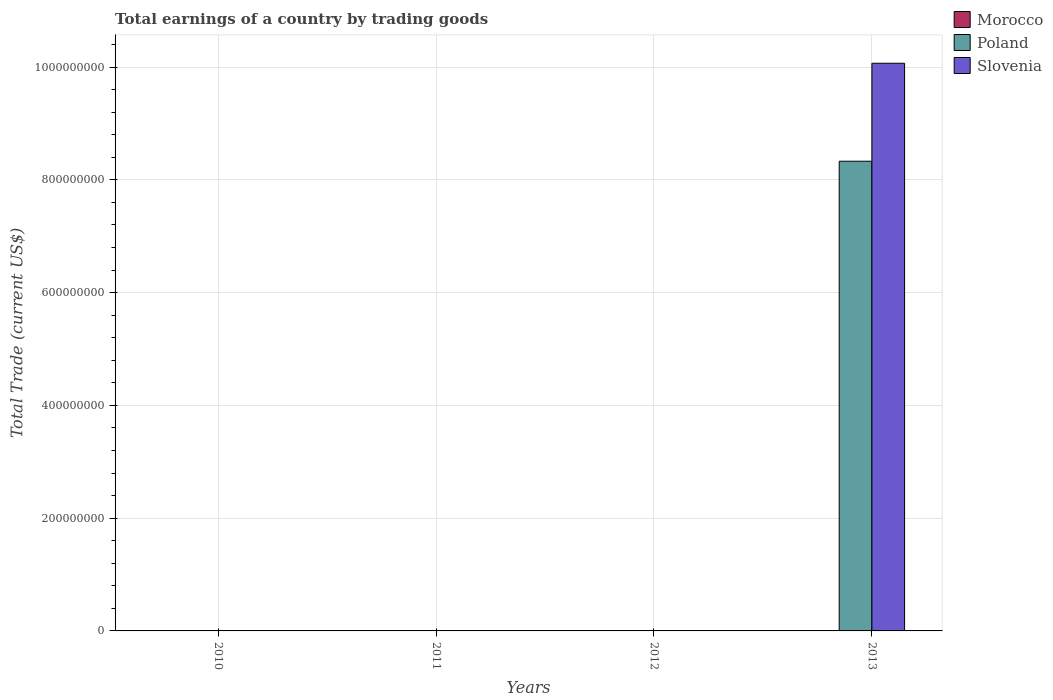How many different coloured bars are there?
Your response must be concise. 2. Are the number of bars on each tick of the X-axis equal?
Your answer should be compact. No. How many bars are there on the 1st tick from the right?
Your answer should be compact. 2. In how many cases, is the number of bars for a given year not equal to the number of legend labels?
Your answer should be compact. 4. What is the total earnings in Poland in 2012?
Provide a succinct answer. 0. Across all years, what is the maximum total earnings in Poland?
Offer a terse response. 8.33e+08. Across all years, what is the minimum total earnings in Slovenia?
Offer a very short reply. 0. What is the total total earnings in Poland in the graph?
Provide a succinct answer. 8.33e+08. What is the difference between the total earnings in Slovenia in 2010 and the total earnings in Poland in 2013?
Make the answer very short. -8.33e+08. What is the average total earnings in Poland per year?
Give a very brief answer. 2.08e+08. What is the difference between the highest and the lowest total earnings in Poland?
Provide a short and direct response. 8.33e+08. In how many years, is the total earnings in Slovenia greater than the average total earnings in Slovenia taken over all years?
Give a very brief answer. 1. How many years are there in the graph?
Ensure brevity in your answer.  4. Are the values on the major ticks of Y-axis written in scientific E-notation?
Your response must be concise. No. Does the graph contain any zero values?
Provide a short and direct response. Yes. Does the graph contain grids?
Make the answer very short. Yes. How many legend labels are there?
Your answer should be compact. 3. How are the legend labels stacked?
Your answer should be very brief. Vertical. What is the title of the graph?
Keep it short and to the point. Total earnings of a country by trading goods. Does "Tunisia" appear as one of the legend labels in the graph?
Provide a succinct answer. No. What is the label or title of the Y-axis?
Your response must be concise. Total Trade (current US$). What is the Total Trade (current US$) of Morocco in 2010?
Your response must be concise. 0. What is the Total Trade (current US$) in Poland in 2010?
Your answer should be very brief. 0. What is the Total Trade (current US$) of Poland in 2012?
Offer a terse response. 0. What is the Total Trade (current US$) of Morocco in 2013?
Provide a short and direct response. 0. What is the Total Trade (current US$) of Poland in 2013?
Keep it short and to the point. 8.33e+08. What is the Total Trade (current US$) in Slovenia in 2013?
Make the answer very short. 1.01e+09. Across all years, what is the maximum Total Trade (current US$) of Poland?
Give a very brief answer. 8.33e+08. Across all years, what is the maximum Total Trade (current US$) of Slovenia?
Ensure brevity in your answer.  1.01e+09. Across all years, what is the minimum Total Trade (current US$) in Poland?
Provide a short and direct response. 0. Across all years, what is the minimum Total Trade (current US$) in Slovenia?
Provide a short and direct response. 0. What is the total Total Trade (current US$) in Morocco in the graph?
Offer a terse response. 0. What is the total Total Trade (current US$) in Poland in the graph?
Keep it short and to the point. 8.33e+08. What is the total Total Trade (current US$) in Slovenia in the graph?
Make the answer very short. 1.01e+09. What is the average Total Trade (current US$) of Poland per year?
Provide a short and direct response. 2.08e+08. What is the average Total Trade (current US$) of Slovenia per year?
Give a very brief answer. 2.52e+08. In the year 2013, what is the difference between the Total Trade (current US$) of Poland and Total Trade (current US$) of Slovenia?
Offer a terse response. -1.74e+08. What is the difference between the highest and the lowest Total Trade (current US$) of Poland?
Make the answer very short. 8.33e+08. What is the difference between the highest and the lowest Total Trade (current US$) in Slovenia?
Ensure brevity in your answer.  1.01e+09. 